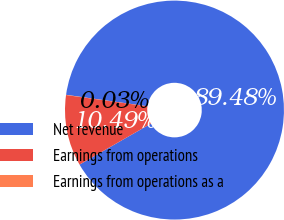<chart> <loc_0><loc_0><loc_500><loc_500><pie_chart><fcel>Net revenue<fcel>Earnings from operations<fcel>Earnings from operations as a<nl><fcel>89.48%<fcel>10.49%<fcel>0.03%<nl></chart> 